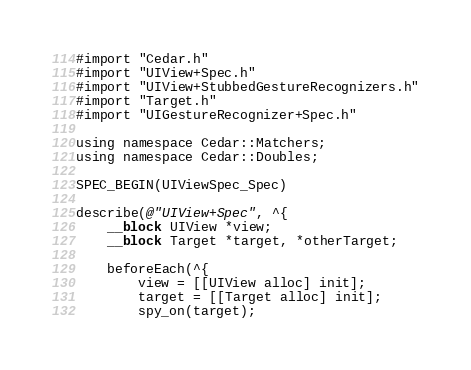Convert code to text. <code><loc_0><loc_0><loc_500><loc_500><_ObjectiveC_>#import "Cedar.h"
#import "UIView+Spec.h"
#import "UIView+StubbedGestureRecognizers.h"
#import "Target.h"
#import "UIGestureRecognizer+Spec.h"

using namespace Cedar::Matchers;
using namespace Cedar::Doubles;

SPEC_BEGIN(UIViewSpec_Spec)

describe(@"UIView+Spec", ^{
    __block UIView *view;
    __block Target *target, *otherTarget;

    beforeEach(^{
        view = [[UIView alloc] init];
        target = [[Target alloc] init];
        spy_on(target);
</code> 